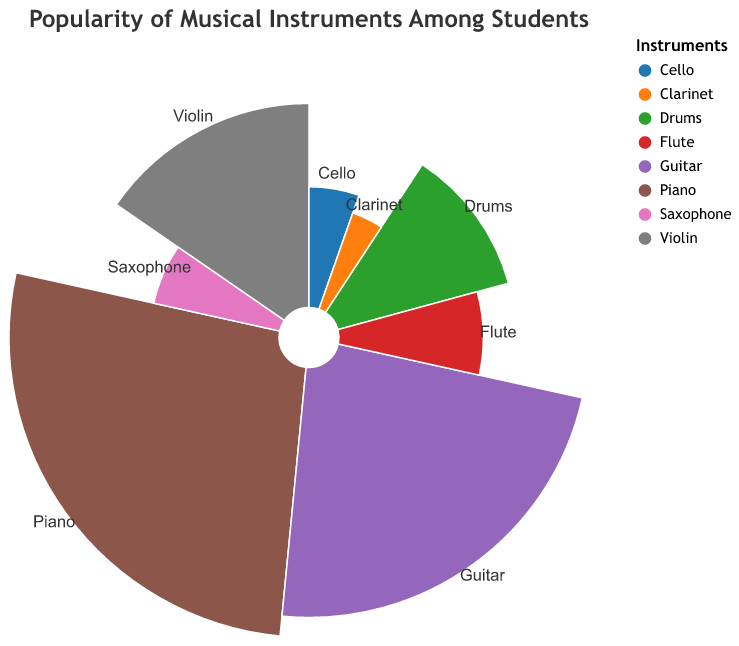What's the title of the chart? The title of the chart is evident from the top of the figure. It gives an immediate indication of the subject being discussed.
Answer: Popularity of Musical Instruments Among Students How many different musical instruments are represented in the chart? The number of different musical instruments can be determined by counting the distinct segments or labels on the polar chart.
Answer: 8 Which musical instrument is the most popular among students? The most popular musical instrument can be identified by looking at the segment with the largest area or the highest value in the chart.
Answer: Piano Which instrument has the least popularity among students? The least popular musical instrument can be identified by finding the smallest segment or the lowest value in the chart.
Answer: Clarinet What's the combined popularity of Piano and Guitar? To find the combined popularity, sum the popularity values for Piano and Guitar. Piano has a popularity of 35 and Guitar has 30. Adding these gives: 35 + 30.
Answer: 65 How much more popular is the Piano compared to the Drums? To determine how much more popular the Piano is compared to the Drums, subtract the popularity of Drums from the popularity of Piano. Piano has 35 and Drums have 15, so 35 - 15 = 20.
Answer: 20 Arrange the instruments in order of their popularity from most to least. To arrange the instruments, list them according to their popularity values from highest to lowest.
Answer: Piano, Guitar, Violin, Drums, Flute, Saxophone, Cello, Clarinet What is the average popularity of all the instruments? To determine the average, sum all the popularity values and divide by the number of instruments. (35+30+20+15+10+8+7+5) / 8 = 130 / 8 = 16.25.
Answer: 16.25 Is there a significant difference in popularity between the third and fourth most popular instruments? The third and fourth most popular instruments are Violin (20) and Drums (15). To see the difference, subtract the popularity of Drums from Violin, 20 - 15 = 5. Yes, there is a 5 point difference.
Answer: Yes, 5 points What proportion of the total popularity is accounted for by the top three instruments? To find the proportion, first determine the total popularity (sum of all values) which is 130. Then sum the popularity of the top three instruments: Piano (35) + Guitar (30) + Violin (20) = 85. Finally, divide 85 by 130 and multiply by 100 to get the percentage: (85/130) * 100.
Answer: 65% 